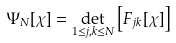<formula> <loc_0><loc_0><loc_500><loc_500>\Psi _ { N } [ \chi ] = \det _ { 1 \leq j , k \leq N } \left [ F _ { j k } [ \chi ] \right ]</formula> 